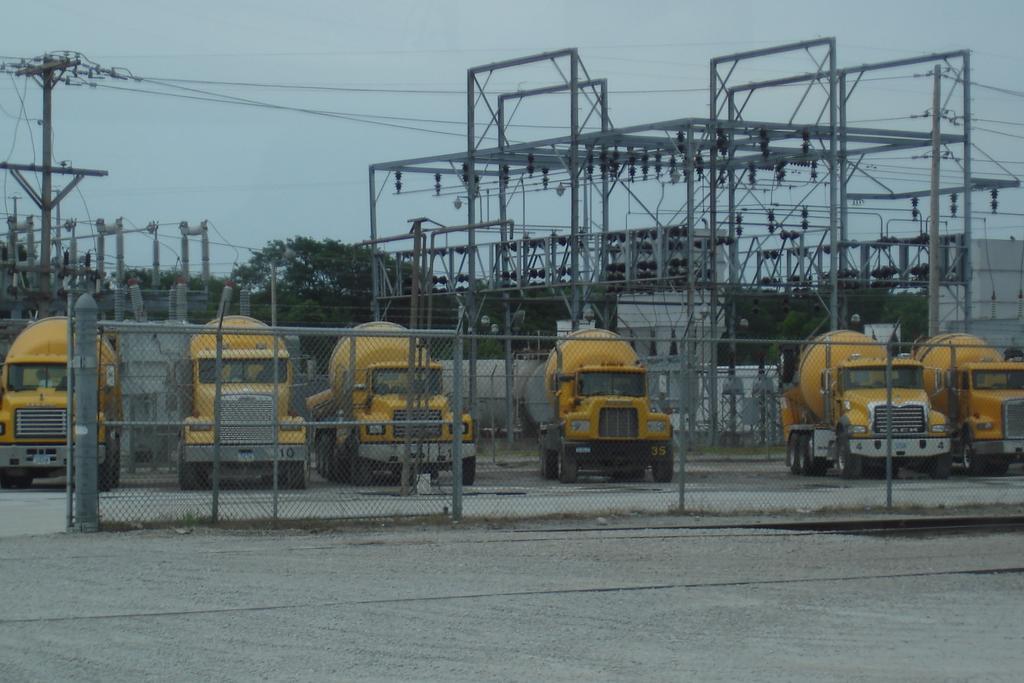In one or two sentences, can you explain what this image depicts? In this image there is the sky towards the top of the image, there are poles, there are wires, there are trees, there are vehicles, there is a fencing, there is a road towards the bottom of the image. 